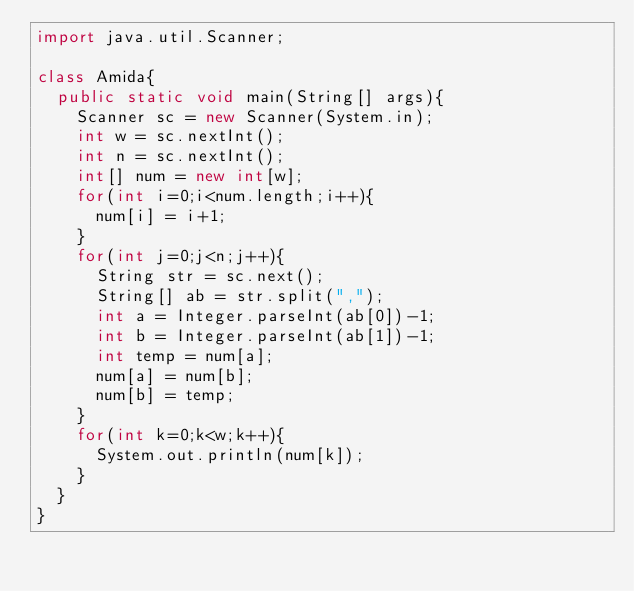Convert code to text. <code><loc_0><loc_0><loc_500><loc_500><_Java_>import java.util.Scanner;

class Amida{
  public static void main(String[] args){
    Scanner sc = new Scanner(System.in);
    int w = sc.nextInt();
    int n = sc.nextInt();
    int[] num = new int[w];
    for(int i=0;i<num.length;i++){
      num[i] = i+1;
    }
    for(int j=0;j<n;j++){
      String str = sc.next();
      String[] ab = str.split(",");
      int a = Integer.parseInt(ab[0])-1;
      int b = Integer.parseInt(ab[1])-1;
      int temp = num[a];
      num[a] = num[b];
      num[b] = temp;
    }
    for(int k=0;k<w;k++){
      System.out.println(num[k]);
    }
  }
}</code> 